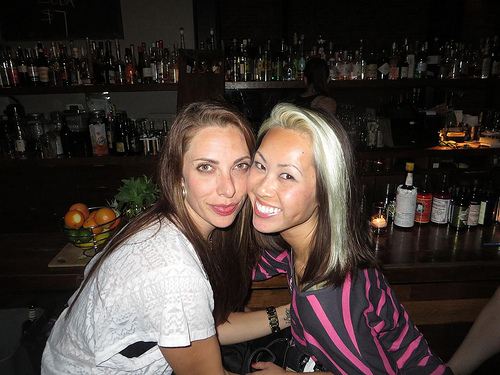<image>
Is the banana to the right of the avocado? No. The banana is not to the right of the avocado. The horizontal positioning shows a different relationship. 